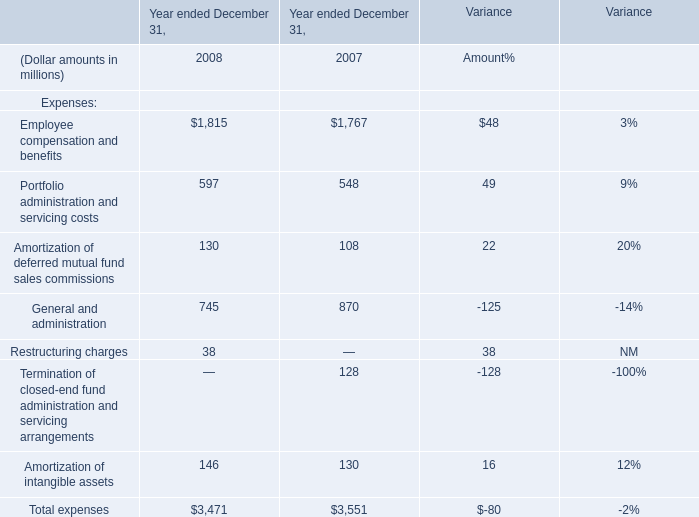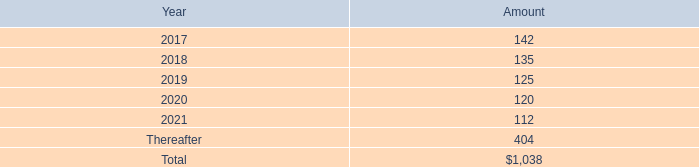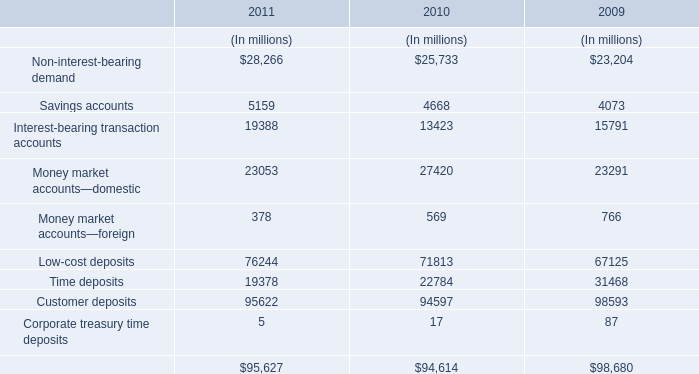What's the current increasing rate of Employee compensation and benefits? 
Computations: ((1815 - 1767) / 1767)
Answer: 0.02716. 